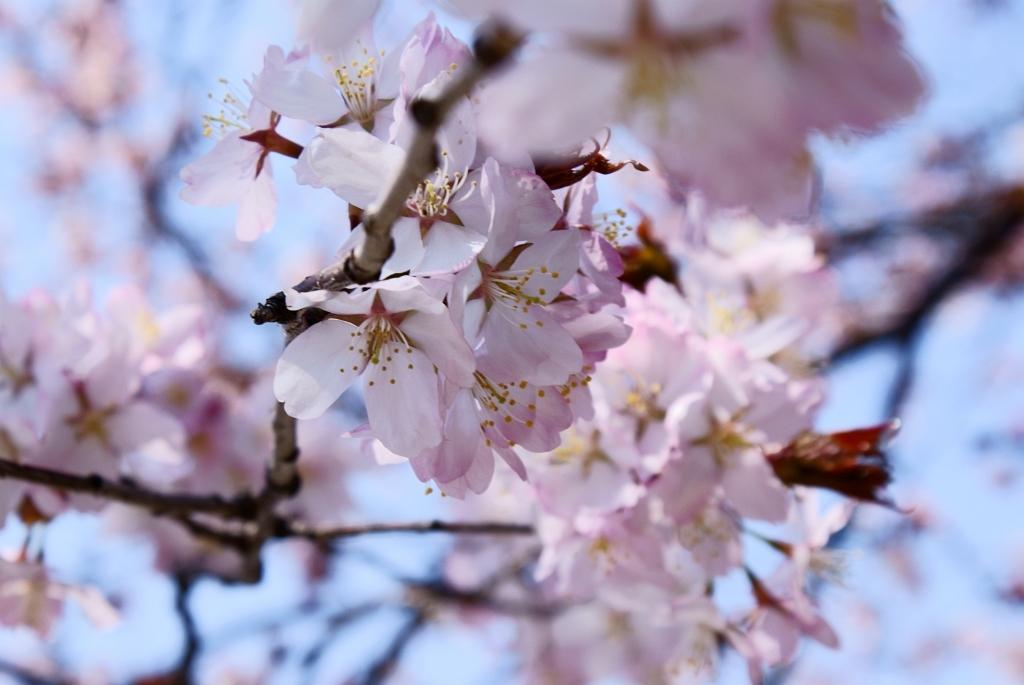What colors are the flowers in the image? The flowers in the image are pink and white. What color is the background of the image? The background of the image is blue. How is the background of the image depicted? The background of the image is blurred. What mass of flowers is being discovered in the image? There is no mention of a mass of flowers being discovered in the image; it simply shows pink and white flowers with a blue background. 